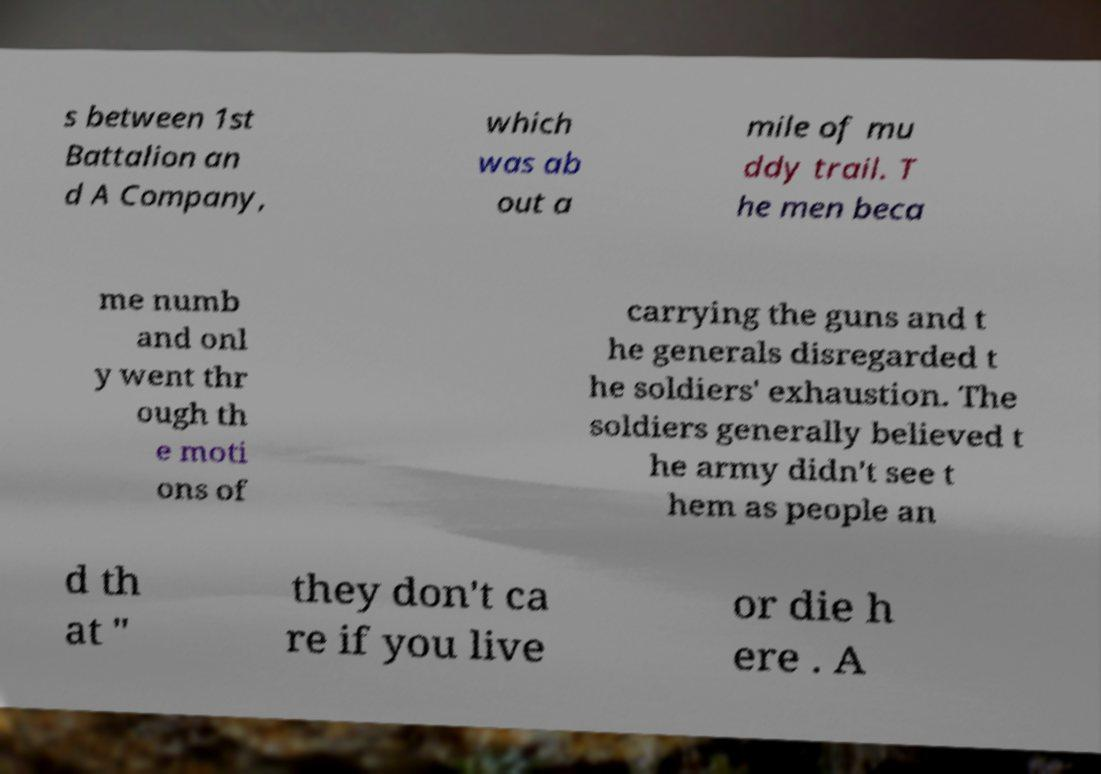I need the written content from this picture converted into text. Can you do that? s between 1st Battalion an d A Company, which was ab out a mile of mu ddy trail. T he men beca me numb and onl y went thr ough th e moti ons of carrying the guns and t he generals disregarded t he soldiers' exhaustion. The soldiers generally believed t he army didn't see t hem as people an d th at " they don't ca re if you live or die h ere . A 